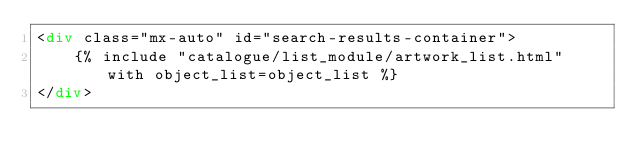<code> <loc_0><loc_0><loc_500><loc_500><_HTML_><div class="mx-auto" id="search-results-container">
    {% include "catalogue/list_module/artwork_list.html" with object_list=object_list %}
</div></code> 